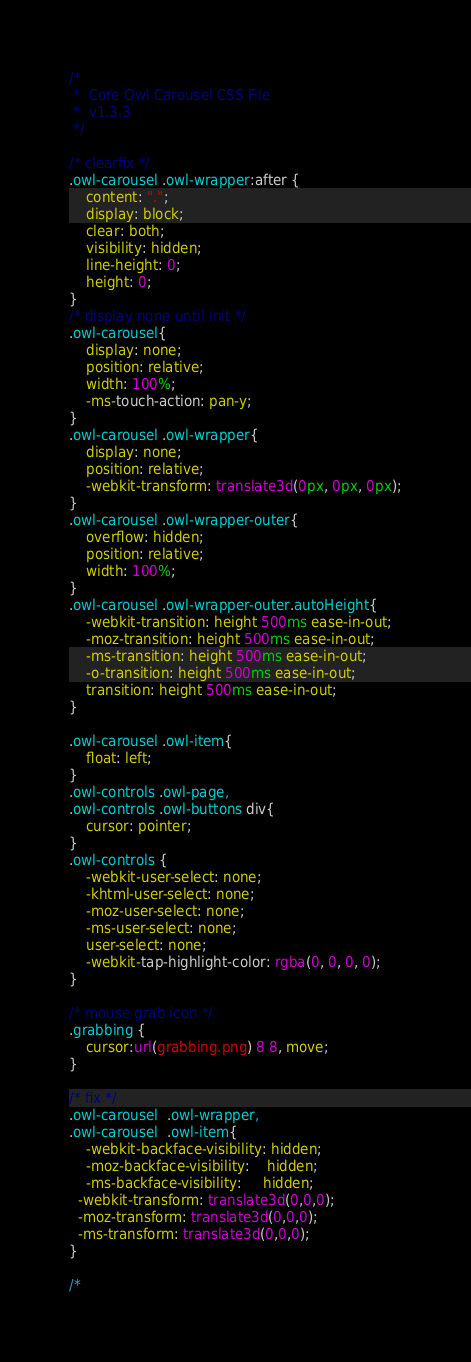Convert code to text. <code><loc_0><loc_0><loc_500><loc_500><_CSS_>/* 
 * 	Core Owl Carousel CSS File
 *	v1.3.3
 */

/* clearfix */
.owl-carousel .owl-wrapper:after {
	content: ".";
	display: block;
	clear: both;
	visibility: hidden;
	line-height: 0;
	height: 0;
}
/* display none until init */
.owl-carousel{
	display: none;
	position: relative;
	width: 100%;
	-ms-touch-action: pan-y;
}
.owl-carousel .owl-wrapper{
	display: none;
	position: relative;
	-webkit-transform: translate3d(0px, 0px, 0px);
}
.owl-carousel .owl-wrapper-outer{
	overflow: hidden;
	position: relative;
	width: 100%;
}
.owl-carousel .owl-wrapper-outer.autoHeight{
	-webkit-transition: height 500ms ease-in-out;
	-moz-transition: height 500ms ease-in-out;
	-ms-transition: height 500ms ease-in-out;
	-o-transition: height 500ms ease-in-out;
	transition: height 500ms ease-in-out;
}
	
.owl-carousel .owl-item{
	float: left;
}
.owl-controls .owl-page,
.owl-controls .owl-buttons div{
	cursor: pointer;
}
.owl-controls {
	-webkit-user-select: none;
	-khtml-user-select: none;
	-moz-user-select: none;
	-ms-user-select: none;
	user-select: none;
	-webkit-tap-highlight-color: rgba(0, 0, 0, 0);
}

/* mouse grab icon */
.grabbing { 
    cursor:url(grabbing.png) 8 8, move;
}

/* fix */
.owl-carousel  .owl-wrapper,
.owl-carousel  .owl-item{
	-webkit-backface-visibility: hidden;
	-moz-backface-visibility:    hidden;
	-ms-backface-visibility:     hidden;
  -webkit-transform: translate3d(0,0,0);
  -moz-transform: translate3d(0,0,0);
  -ms-transform: translate3d(0,0,0);
}

/*</code> 